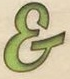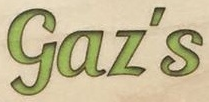What words are shown in these images in order, separated by a semicolon? &; Gaz's 